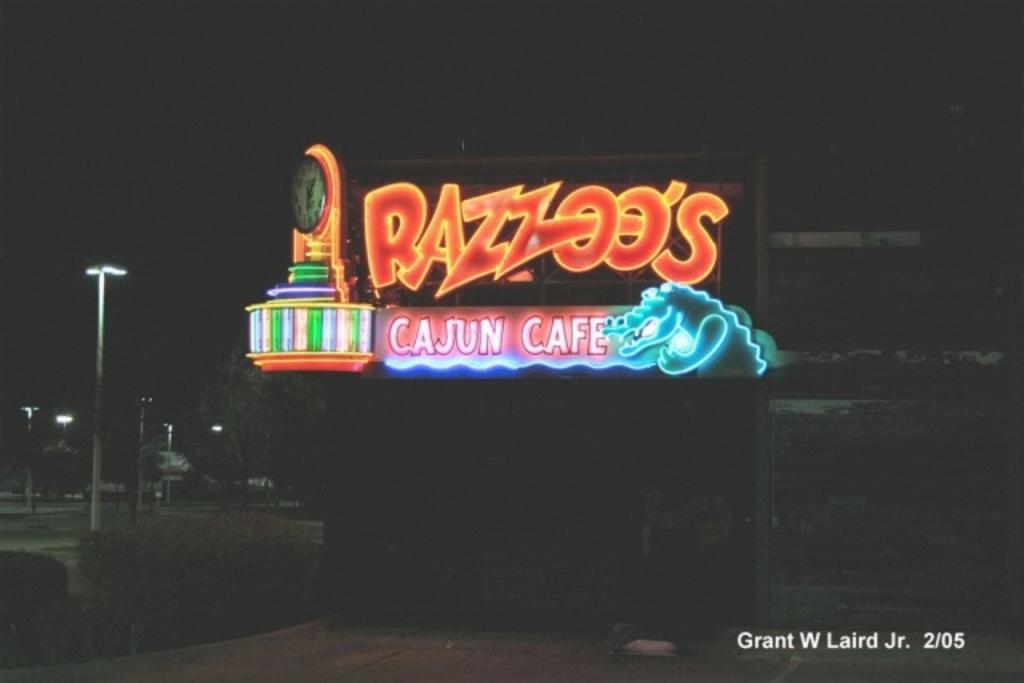<image>
Summarize the visual content of the image. Neon lights sign brightly in the night sky above Razzoo's. 